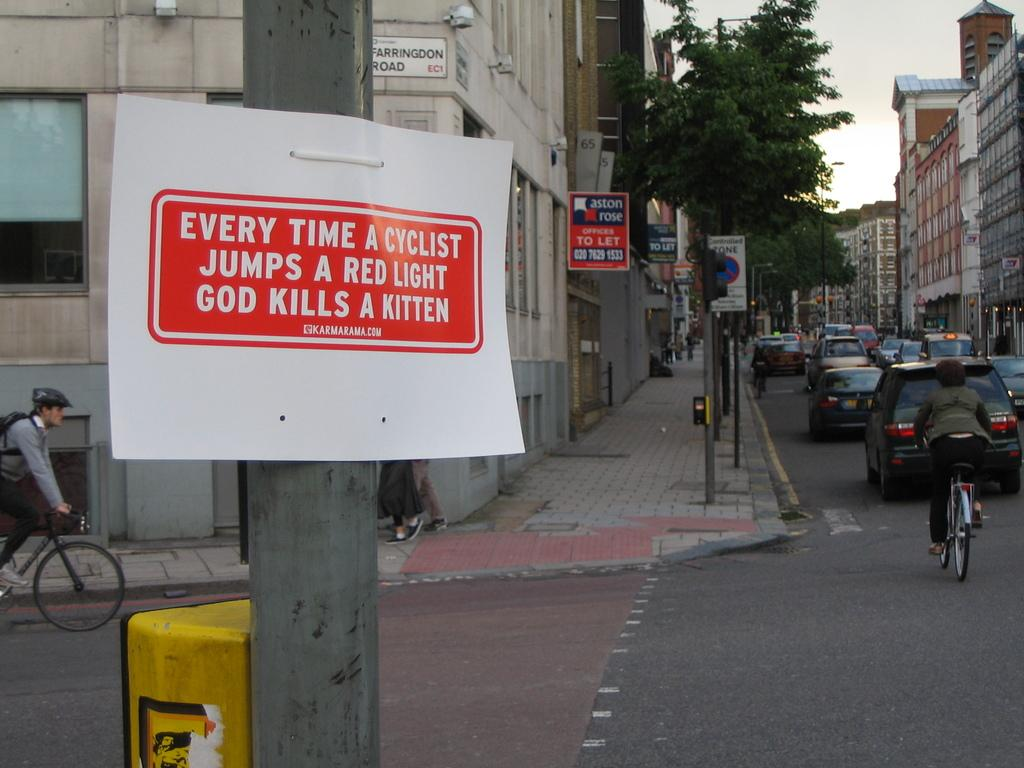<image>
Present a compact description of the photo's key features. A sign on a pole says "Every time a cyclist jumps a red light God kills a kitten." 